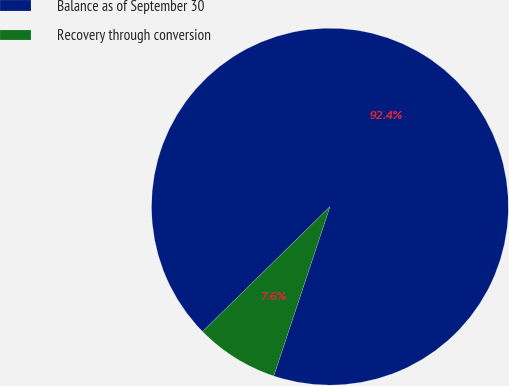<chart> <loc_0><loc_0><loc_500><loc_500><pie_chart><fcel>Balance as of September 30<fcel>Recovery through conversion<nl><fcel>92.45%<fcel>7.55%<nl></chart> 